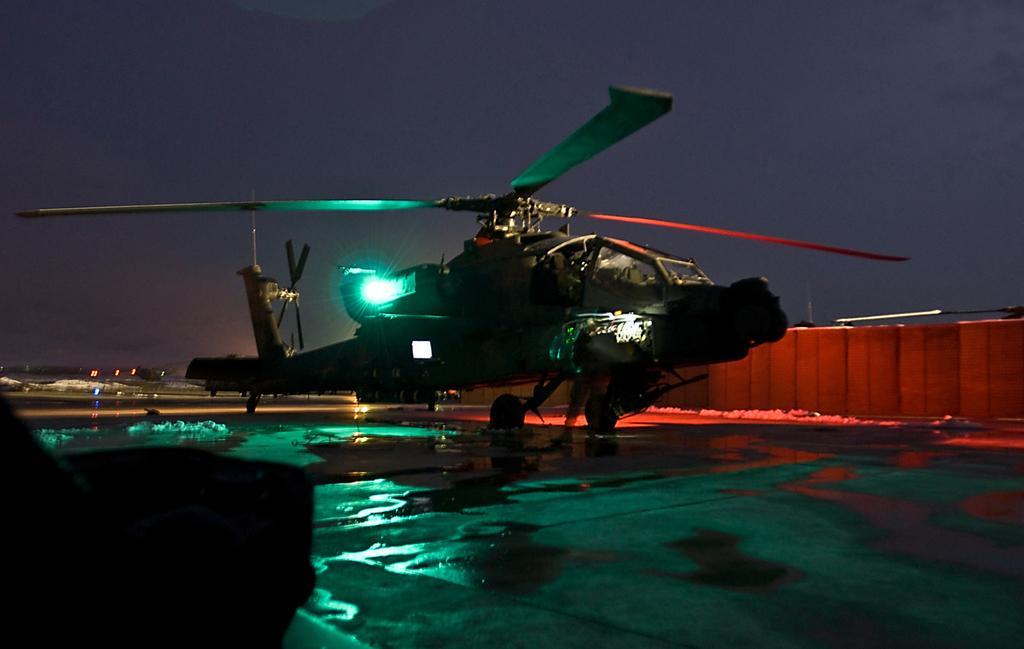Could you give a brief overview of what you see in this image? There is a helicopter with light on the ground. On the sides there is wall. In the background there is sky. 